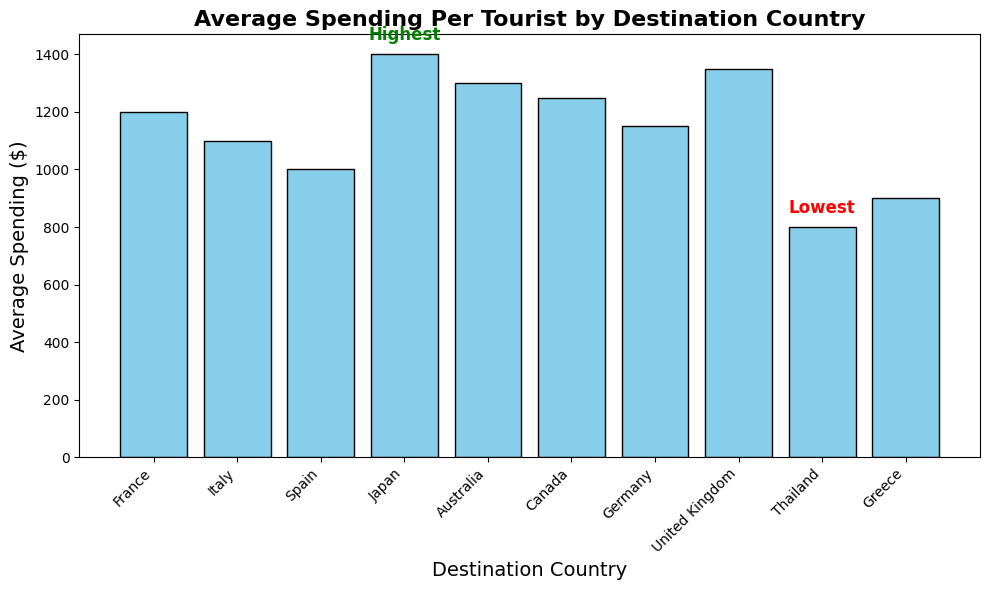What is the highest average spending per tourist among the countries? The highest average spending is indicated by the bar with the greatest height and the 'Highest' text annotation in green.
Answer: $1400 What is the lowest average spending per tourist among the countries? The lowest average spending is indicated by the bar with the smallest height and the 'Lowest' text annotation in red.
Answer: $800 Which country has an average spending higher than Australia but lower than Japan? To answer this, identify the average spending for both Australia ($1300) and Japan ($1400), then find the country with average spending between these values.
Answer: United Kingdom How much more do tourists spend on average in Japan compared to Spain? Identify the average spending in Japan ($1400) and in Spain ($1000), then find their difference: $1400 - $1000.
Answer: $400 Which country has an average spending closest to $1200? Check the average spending amounts and find the country closest to $1200. France has an average spending of $1200.
Answer: France Between Italy and Germany, which country has the higher average spending per tourist? Compare the average spending for Italy ($1100) and Germany ($1150).
Answer: Germany What is the total average spending for tourists in France and Italy combined? Sum the average spending for France ($1200) and Italy ($1100): $1200 + $1100.
Answer: $2300 How does the average spending in Canada compare to that in Germany? Compare the average spending amounts for Canada ($1250) and Germany ($1150).
Answer: Canada spends $100 more What is the difference in average spending per tourist between the United Kingdom and Thailand? Identify the average spending in the United Kingdom ($1350) and in Thailand ($800), then find their difference: $1350 - $800.
Answer: $550 Which two countries have average spending amounts closest to the average of Japan and Australia? First, calculate the average spending for Japan ($1400) and Australia ($1300), which is ($1400 + $1300)/2 = $1350. Then, find the two countries with values closest to $1350.
Answer: United Kingdom and Canada 